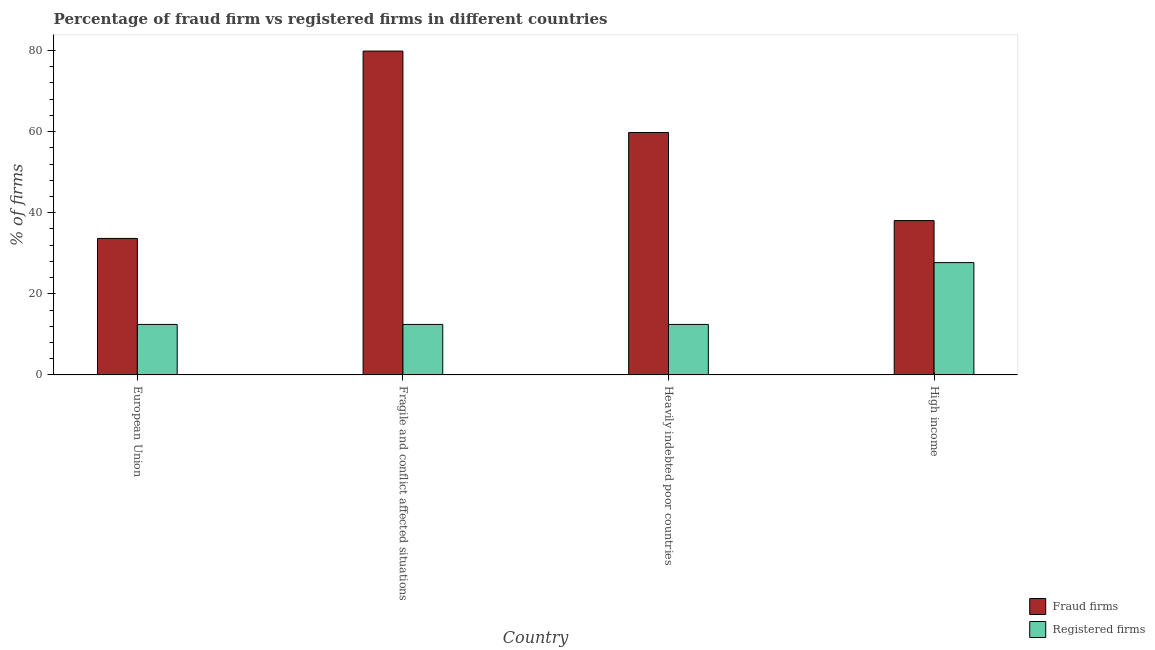How many different coloured bars are there?
Provide a succinct answer. 2. Are the number of bars per tick equal to the number of legend labels?
Ensure brevity in your answer.  Yes. Are the number of bars on each tick of the X-axis equal?
Offer a very short reply. Yes. How many bars are there on the 1st tick from the right?
Your response must be concise. 2. What is the label of the 2nd group of bars from the left?
Ensure brevity in your answer.  Fragile and conflict affected situations. In how many cases, is the number of bars for a given country not equal to the number of legend labels?
Give a very brief answer. 0. What is the percentage of fraud firms in Fragile and conflict affected situations?
Provide a succinct answer. 79.87. Across all countries, what is the maximum percentage of fraud firms?
Provide a short and direct response. 79.87. Across all countries, what is the minimum percentage of registered firms?
Your answer should be compact. 12.45. In which country was the percentage of fraud firms maximum?
Provide a succinct answer. Fragile and conflict affected situations. What is the total percentage of registered firms in the graph?
Offer a terse response. 65.05. What is the difference between the percentage of registered firms in European Union and that in High income?
Ensure brevity in your answer.  -15.25. What is the difference between the percentage of fraud firms in European Union and the percentage of registered firms in High income?
Provide a short and direct response. 5.96. What is the average percentage of registered firms per country?
Ensure brevity in your answer.  16.26. What is the difference between the percentage of fraud firms and percentage of registered firms in Fragile and conflict affected situations?
Give a very brief answer. 67.42. In how many countries, is the percentage of registered firms greater than 56 %?
Provide a short and direct response. 0. What is the ratio of the percentage of registered firms in European Union to that in High income?
Make the answer very short. 0.45. Is the difference between the percentage of registered firms in Fragile and conflict affected situations and High income greater than the difference between the percentage of fraud firms in Fragile and conflict affected situations and High income?
Make the answer very short. No. What is the difference between the highest and the second highest percentage of registered firms?
Ensure brevity in your answer.  15.25. What is the difference between the highest and the lowest percentage of fraud firms?
Provide a succinct answer. 46.21. What does the 1st bar from the left in High income represents?
Your answer should be very brief. Fraud firms. What does the 2nd bar from the right in European Union represents?
Provide a short and direct response. Fraud firms. How many bars are there?
Your answer should be very brief. 8. How many countries are there in the graph?
Offer a very short reply. 4. Does the graph contain any zero values?
Your answer should be very brief. No. Where does the legend appear in the graph?
Provide a succinct answer. Bottom right. How are the legend labels stacked?
Your answer should be very brief. Vertical. What is the title of the graph?
Make the answer very short. Percentage of fraud firm vs registered firms in different countries. Does "Investments" appear as one of the legend labels in the graph?
Ensure brevity in your answer.  No. What is the label or title of the X-axis?
Keep it short and to the point. Country. What is the label or title of the Y-axis?
Ensure brevity in your answer.  % of firms. What is the % of firms of Fraud firms in European Union?
Offer a terse response. 33.66. What is the % of firms of Registered firms in European Union?
Provide a succinct answer. 12.45. What is the % of firms in Fraud firms in Fragile and conflict affected situations?
Your answer should be compact. 79.87. What is the % of firms in Registered firms in Fragile and conflict affected situations?
Your response must be concise. 12.45. What is the % of firms in Fraud firms in Heavily indebted poor countries?
Keep it short and to the point. 59.79. What is the % of firms of Registered firms in Heavily indebted poor countries?
Your answer should be very brief. 12.45. What is the % of firms of Fraud firms in High income?
Your answer should be compact. 38.06. What is the % of firms in Registered firms in High income?
Offer a terse response. 27.7. Across all countries, what is the maximum % of firms in Fraud firms?
Offer a terse response. 79.87. Across all countries, what is the maximum % of firms in Registered firms?
Offer a terse response. 27.7. Across all countries, what is the minimum % of firms of Fraud firms?
Provide a succinct answer. 33.66. Across all countries, what is the minimum % of firms of Registered firms?
Your response must be concise. 12.45. What is the total % of firms in Fraud firms in the graph?
Ensure brevity in your answer.  211.38. What is the total % of firms in Registered firms in the graph?
Provide a short and direct response. 65.05. What is the difference between the % of firms of Fraud firms in European Union and that in Fragile and conflict affected situations?
Offer a very short reply. -46.21. What is the difference between the % of firms in Registered firms in European Union and that in Fragile and conflict affected situations?
Your answer should be compact. 0. What is the difference between the % of firms in Fraud firms in European Union and that in Heavily indebted poor countries?
Ensure brevity in your answer.  -26.13. What is the difference between the % of firms of Fraud firms in European Union and that in High income?
Ensure brevity in your answer.  -4.4. What is the difference between the % of firms in Registered firms in European Union and that in High income?
Your answer should be very brief. -15.25. What is the difference between the % of firms of Fraud firms in Fragile and conflict affected situations and that in Heavily indebted poor countries?
Ensure brevity in your answer.  20.08. What is the difference between the % of firms of Fraud firms in Fragile and conflict affected situations and that in High income?
Provide a succinct answer. 41.81. What is the difference between the % of firms in Registered firms in Fragile and conflict affected situations and that in High income?
Provide a succinct answer. -15.25. What is the difference between the % of firms in Fraud firms in Heavily indebted poor countries and that in High income?
Offer a terse response. 21.73. What is the difference between the % of firms in Registered firms in Heavily indebted poor countries and that in High income?
Your response must be concise. -15.25. What is the difference between the % of firms of Fraud firms in European Union and the % of firms of Registered firms in Fragile and conflict affected situations?
Your answer should be compact. 21.21. What is the difference between the % of firms in Fraud firms in European Union and the % of firms in Registered firms in Heavily indebted poor countries?
Offer a terse response. 21.21. What is the difference between the % of firms in Fraud firms in European Union and the % of firms in Registered firms in High income?
Keep it short and to the point. 5.96. What is the difference between the % of firms of Fraud firms in Fragile and conflict affected situations and the % of firms of Registered firms in Heavily indebted poor countries?
Your response must be concise. 67.42. What is the difference between the % of firms of Fraud firms in Fragile and conflict affected situations and the % of firms of Registered firms in High income?
Offer a terse response. 52.17. What is the difference between the % of firms in Fraud firms in Heavily indebted poor countries and the % of firms in Registered firms in High income?
Give a very brief answer. 32.09. What is the average % of firms in Fraud firms per country?
Offer a terse response. 52.84. What is the average % of firms in Registered firms per country?
Ensure brevity in your answer.  16.26. What is the difference between the % of firms of Fraud firms and % of firms of Registered firms in European Union?
Keep it short and to the point. 21.21. What is the difference between the % of firms of Fraud firms and % of firms of Registered firms in Fragile and conflict affected situations?
Keep it short and to the point. 67.42. What is the difference between the % of firms of Fraud firms and % of firms of Registered firms in Heavily indebted poor countries?
Your answer should be compact. 47.34. What is the difference between the % of firms of Fraud firms and % of firms of Registered firms in High income?
Provide a succinct answer. 10.36. What is the ratio of the % of firms of Fraud firms in European Union to that in Fragile and conflict affected situations?
Your response must be concise. 0.42. What is the ratio of the % of firms in Registered firms in European Union to that in Fragile and conflict affected situations?
Make the answer very short. 1. What is the ratio of the % of firms in Fraud firms in European Union to that in Heavily indebted poor countries?
Give a very brief answer. 0.56. What is the ratio of the % of firms in Registered firms in European Union to that in Heavily indebted poor countries?
Your answer should be compact. 1. What is the ratio of the % of firms of Fraud firms in European Union to that in High income?
Make the answer very short. 0.88. What is the ratio of the % of firms in Registered firms in European Union to that in High income?
Provide a short and direct response. 0.45. What is the ratio of the % of firms in Fraud firms in Fragile and conflict affected situations to that in Heavily indebted poor countries?
Make the answer very short. 1.34. What is the ratio of the % of firms in Fraud firms in Fragile and conflict affected situations to that in High income?
Provide a succinct answer. 2.1. What is the ratio of the % of firms in Registered firms in Fragile and conflict affected situations to that in High income?
Ensure brevity in your answer.  0.45. What is the ratio of the % of firms of Fraud firms in Heavily indebted poor countries to that in High income?
Your answer should be compact. 1.57. What is the ratio of the % of firms of Registered firms in Heavily indebted poor countries to that in High income?
Ensure brevity in your answer.  0.45. What is the difference between the highest and the second highest % of firms of Fraud firms?
Your response must be concise. 20.08. What is the difference between the highest and the second highest % of firms of Registered firms?
Provide a short and direct response. 15.25. What is the difference between the highest and the lowest % of firms in Fraud firms?
Provide a short and direct response. 46.21. What is the difference between the highest and the lowest % of firms of Registered firms?
Offer a very short reply. 15.25. 